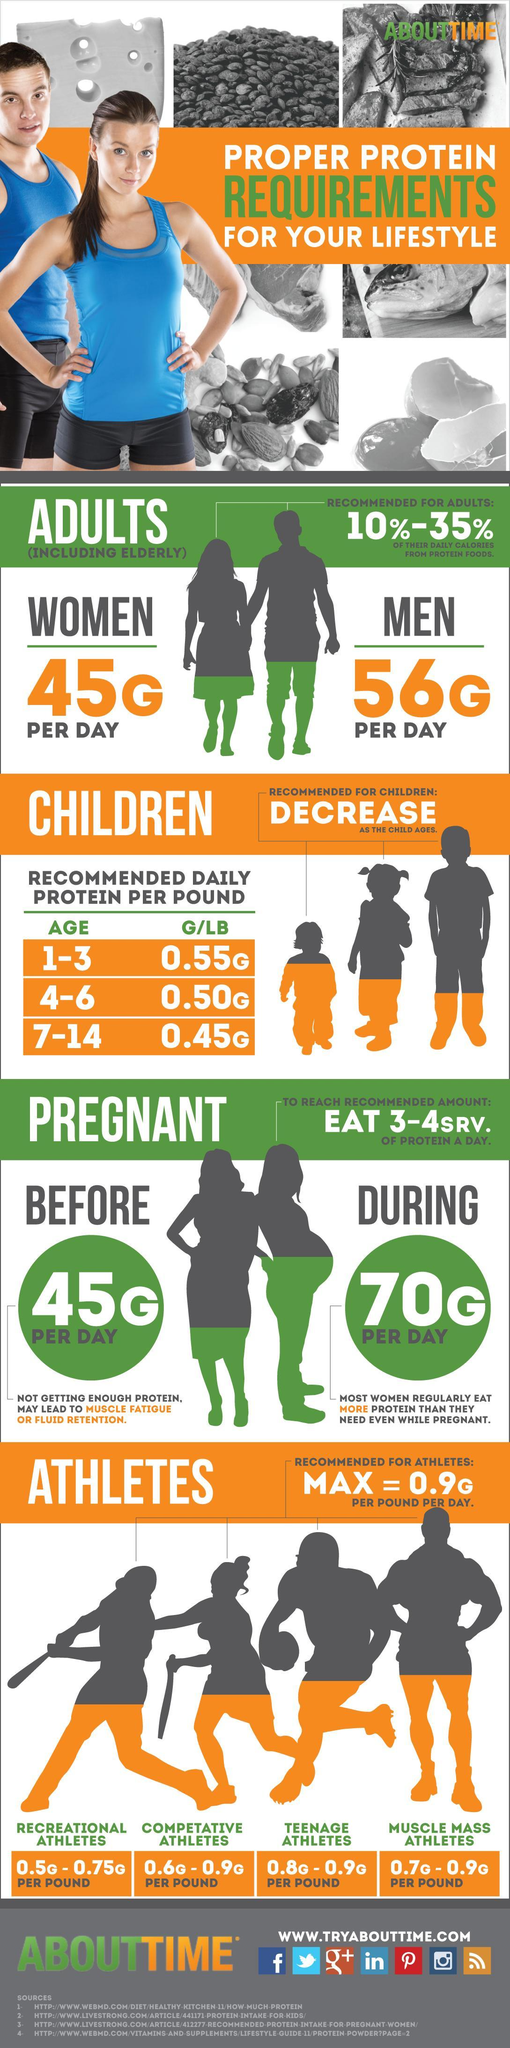What is the amount of protein intake recommended for a pregnant woman in a day?
Answer the question with a short phrase. 70G What is the minimum protein requirement for recreational athletes per pound per day? 0.5G What is the amount of protein recommended per pound for children in the age group of 7-14 years? 0.45G How much protein should a man eat in a day? 56G PER DAY What is the amount of protein intake recommended for a woman per day before getting pregnant? 45G Which age group of children needs the most protein? 1-3 What is the amount of protein recommended per pound for teenage athletes per day? 0.8G - 0.9G How much protein should a woman eat in a day? 45G 